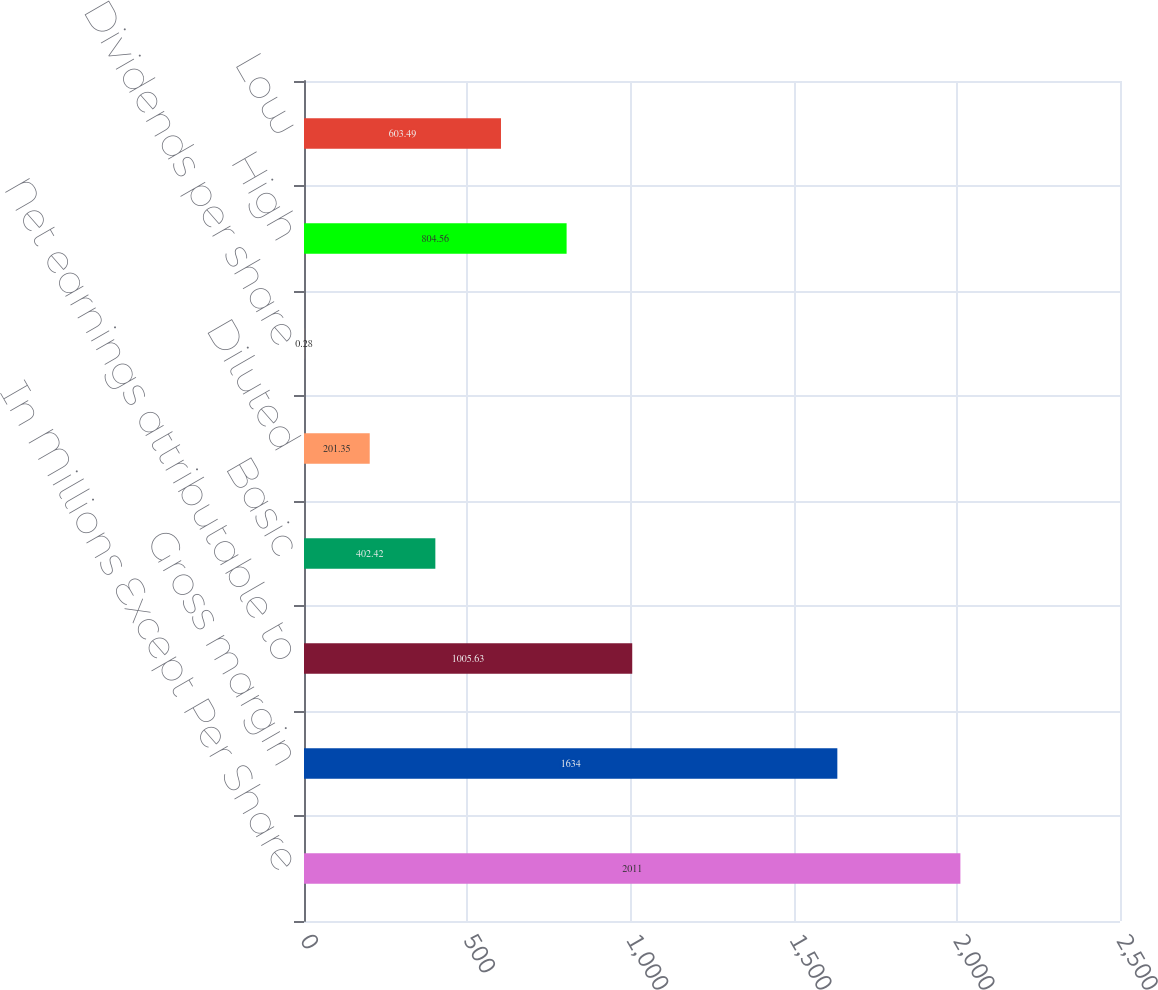Convert chart to OTSL. <chart><loc_0><loc_0><loc_500><loc_500><bar_chart><fcel>In Millions Except Per Share<fcel>Gross margin<fcel>Net earnings attributable to<fcel>Basic<fcel>Diluted<fcel>Dividends per share<fcel>High<fcel>Low<nl><fcel>2011<fcel>1634<fcel>1005.63<fcel>402.42<fcel>201.35<fcel>0.28<fcel>804.56<fcel>603.49<nl></chart> 